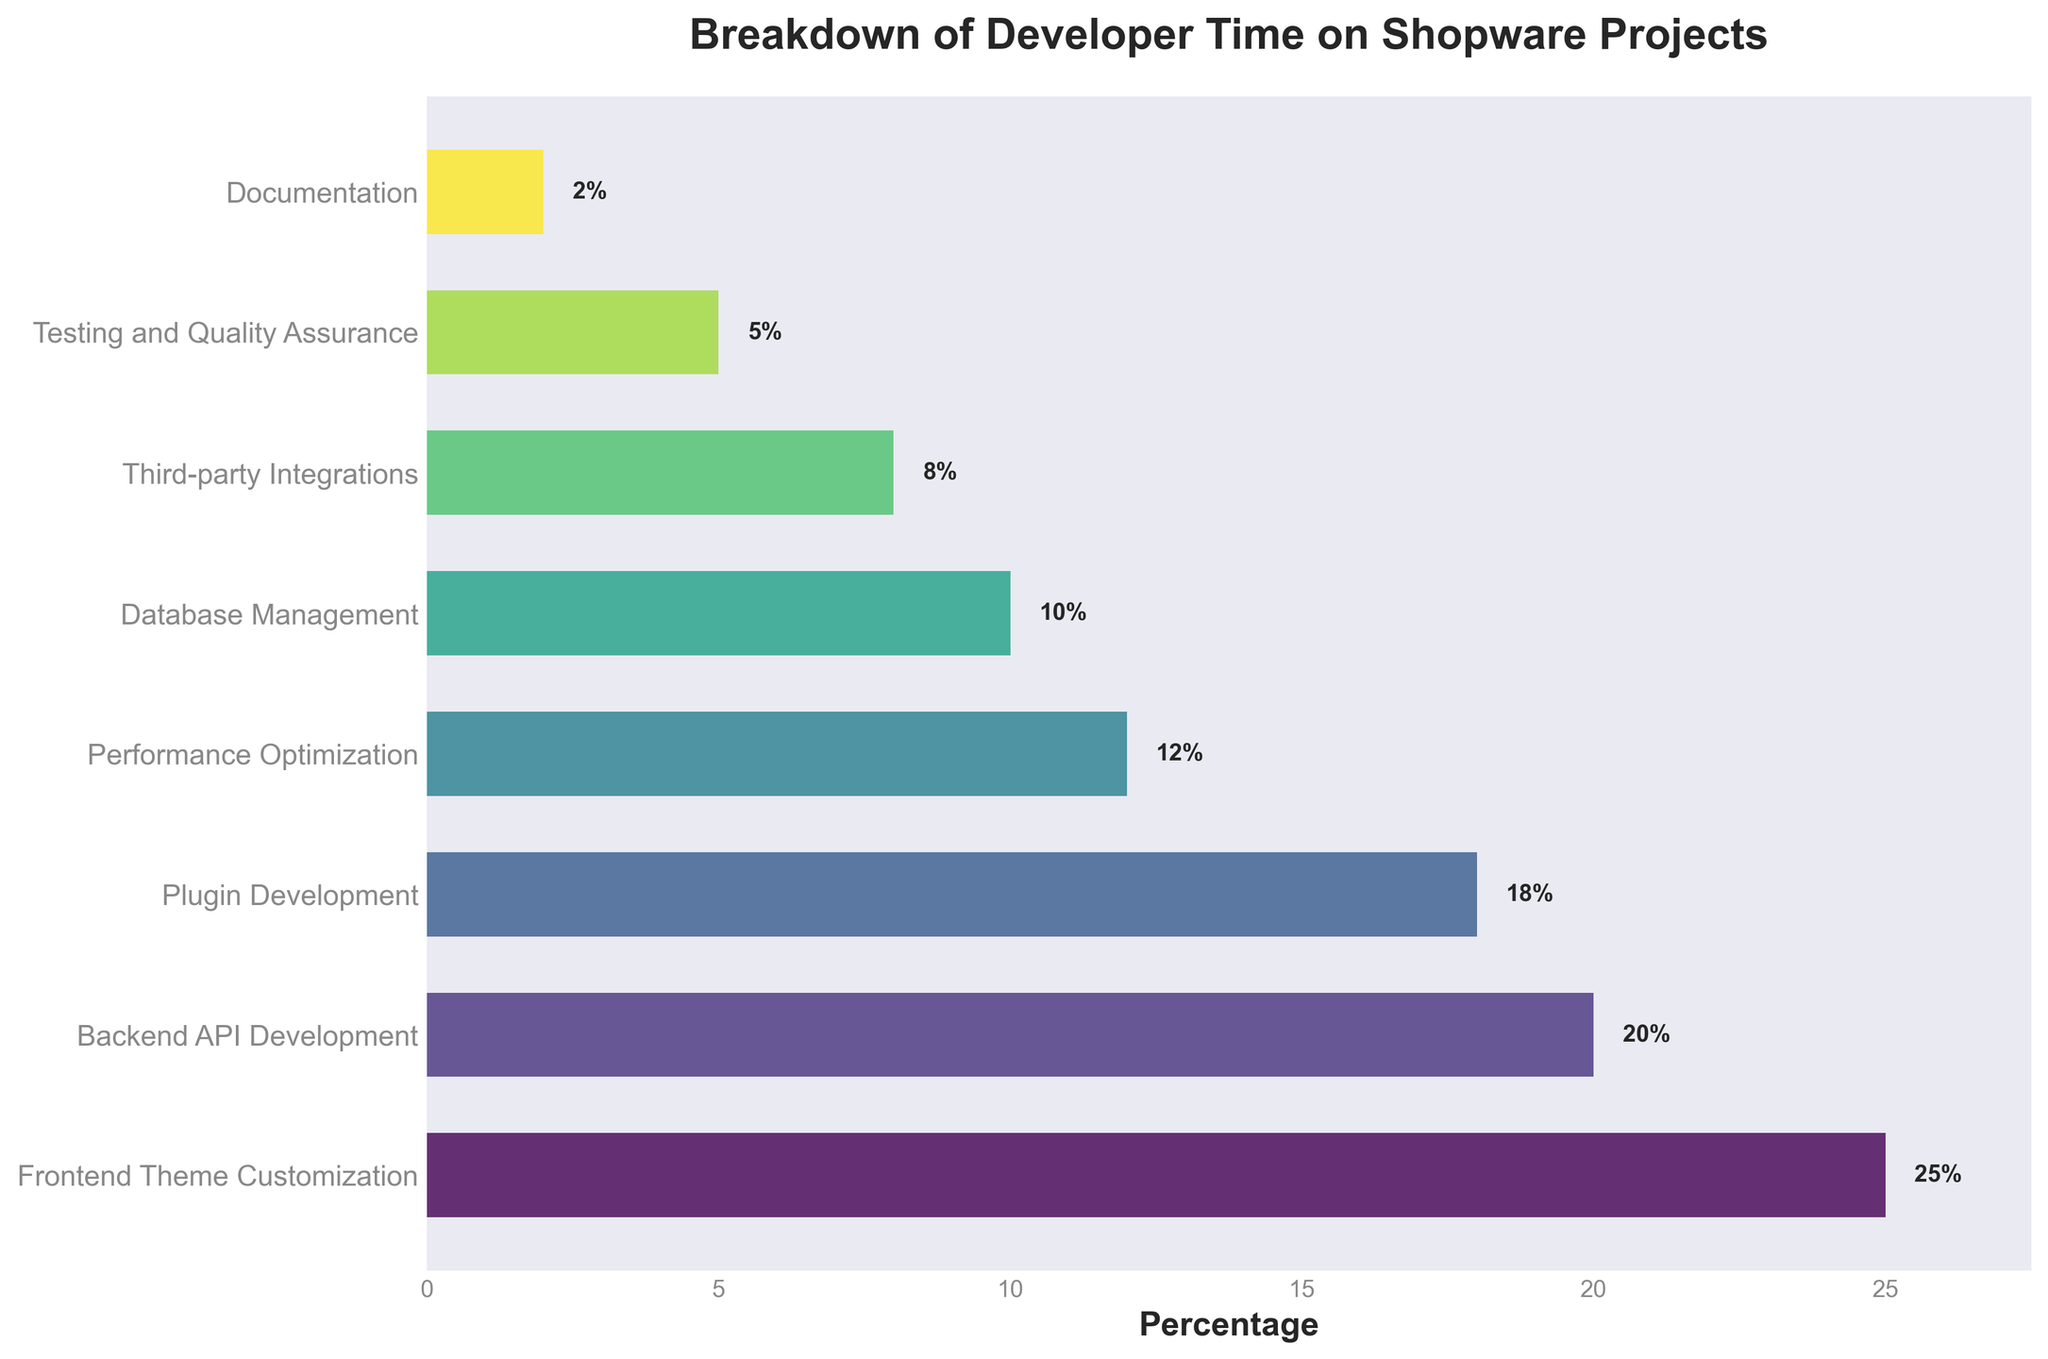Which aspect of Shopware projects takes the most developer time? The bar chart's title indicates it's about the Breakdown of Developer Time on Shopware Projects. The longest bar, indicating the highest percentage, represents "Frontend Theme Customization" at 25%.
Answer: Frontend Theme Customization How much more time is spent on Backend API Development compared to Documentation? "Backend API Development" shows 20% and "Documentation" shows 2%. Subtracting these percentages gives 20% - 2% = 18%.
Answer: 18% What is the combined percentage of time spent on Plugin Development and Third-party Integrations? From the chart: "Plugin Development" is 18% and "Third-party Integrations" is 8%. Adding these percentages gives 18% + 8% = 26%.
Answer: 26% Which two aspects have the smallest percentages, and what are their values? The shortest bars are for "Testing and Quality Assurance" and "Documentation" at 5% and 2%, respectively.
Answer: Testing and Quality Assurance (5%), Documentation (2%) Is more time spent on Frontend Theme Customization or Performance Optimization, and by how much? "Frontend Theme Customization" is at 25% while "Performance Optimization" is at 12%. Subtracting these values gives 25% - 12% = 13%.
Answer: Frontend Theme Customization, 13% What is the total percentage of time spent on Backend API Development, Performance Optimization, and Database Management combined? From the chart: "Backend API Development" is 20%, "Performance Optimization" is 12%, and "Database Management" is 10%. Adding these percentages gives 20% + 12% + 10% = 42%.
Answer: 42% Which aspect has a higher percentage, Performance Optimization or Third-party Integrations? "Performance Optimization" is at 12% and "Third-party Integrations" is at 8%. 12% is greater than 8%.
Answer: Performance Optimization How much time is spent on aspects related to coding (Frontend Theme Customization, Backend API Development, and Plugin Development)? The aspects' percentages are: "Frontend Theme Customization" at 25%, "Backend API Development" at 20%, and "Plugin Development" at 18%. Adding these gives 25% + 20% + 18% = 63%.
Answer: 63% Rank the top three aspects of developer time spent in descending order. The top three aspects are: 1. "Frontend Theme Customization" at 25%, 2. "Backend API Development" at 20%, 3. "Plugin Development" at 18%.
Answer: Frontend Theme Customization > Backend API Development > Plugin Development 